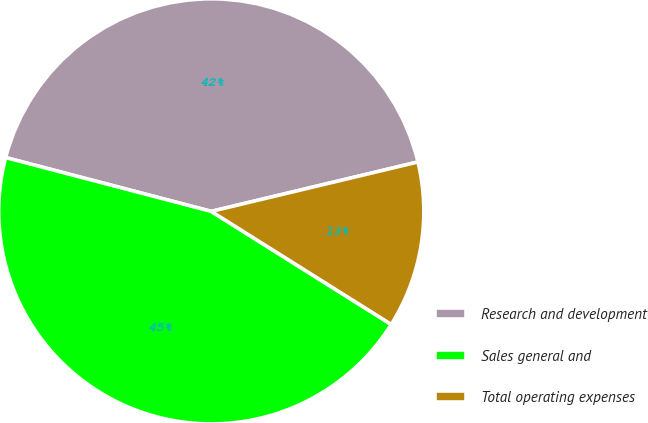Convert chart. <chart><loc_0><loc_0><loc_500><loc_500><pie_chart><fcel>Research and development<fcel>Sales general and<fcel>Total operating expenses<nl><fcel>42.19%<fcel>45.15%<fcel>12.66%<nl></chart> 